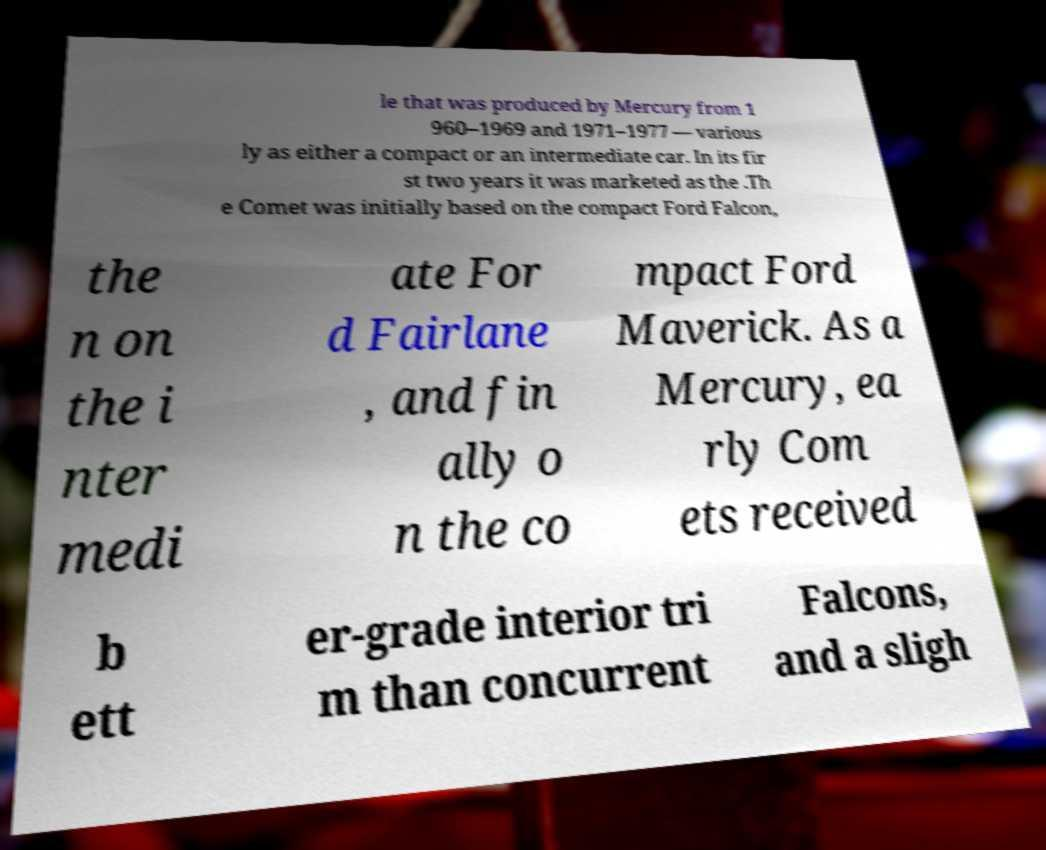There's text embedded in this image that I need extracted. Can you transcribe it verbatim? le that was produced by Mercury from 1 960–1969 and 1971–1977 — various ly as either a compact or an intermediate car. In its fir st two years it was marketed as the .Th e Comet was initially based on the compact Ford Falcon, the n on the i nter medi ate For d Fairlane , and fin ally o n the co mpact Ford Maverick. As a Mercury, ea rly Com ets received b ett er-grade interior tri m than concurrent Falcons, and a sligh 